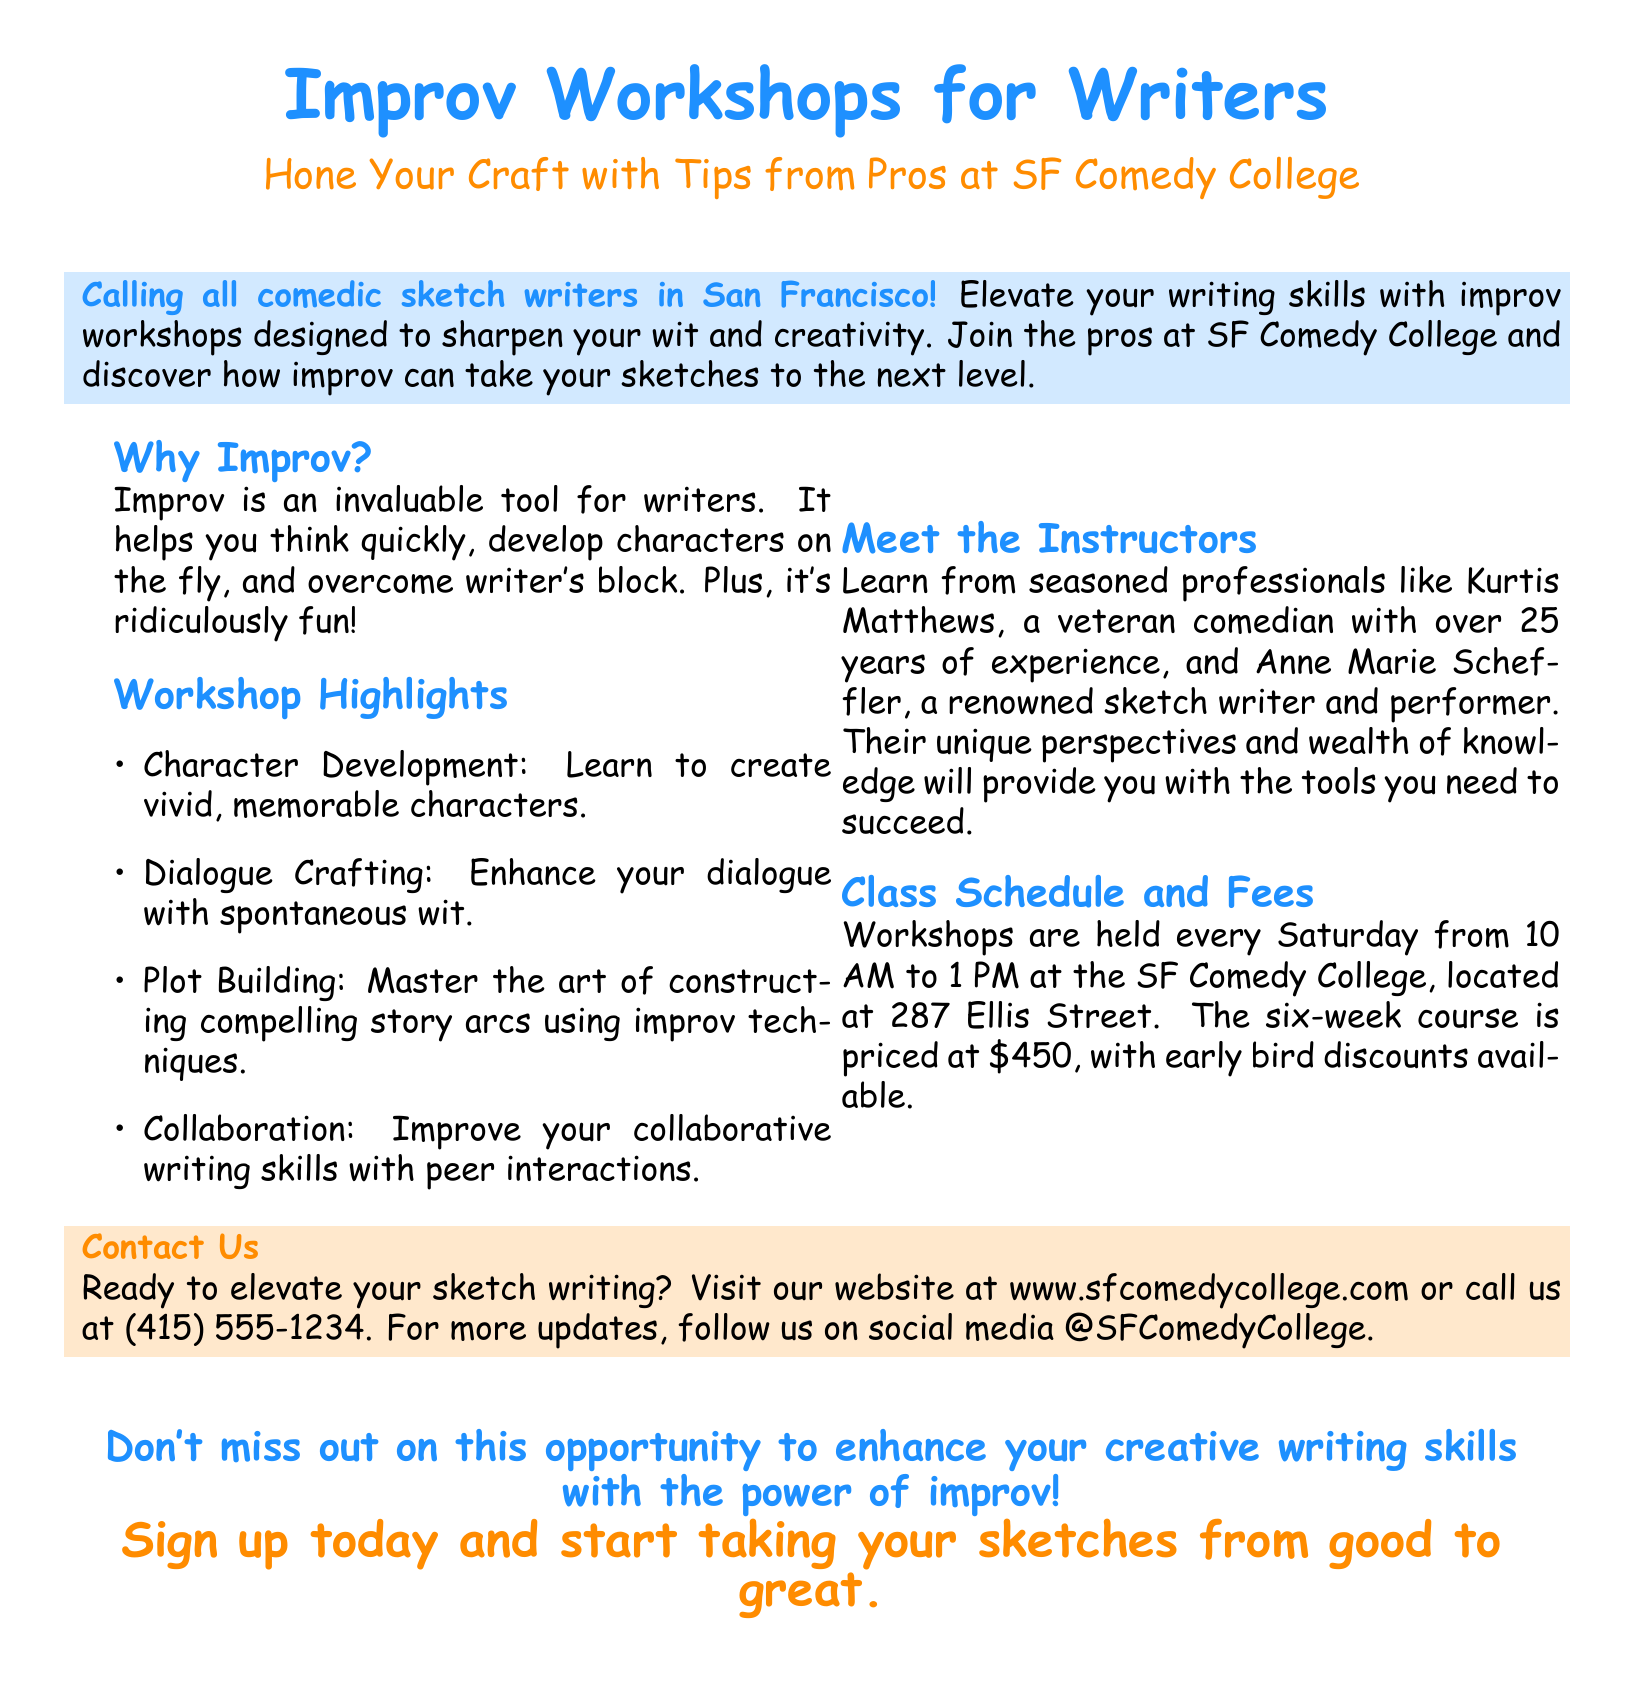What is the location of the workshops? The workshops are held at the SF Comedy College, located at 287 Ellis Street.
Answer: 287 Ellis Street Who is one of the instructors? The document mentions Kurtis Matthews and Anne Marie Scheffler as instructors.
Answer: Kurtis Matthews What day of the week are the workshops conducted? The document specifies that workshops are held every Saturday.
Answer: Saturday What is the total duration of the course? The document states that the course is a six-week workshop.
Answer: six weeks What time do the workshops start? The start time for the workshops is listed as 10 AM.
Answer: 10 AM What is the price of the six-week course? The document specifies that the course costs $450.
Answer: $450 What skill does improv help writers develop? The document suggests that improv helps writers think quickly.
Answer: think quickly Which two aspects of writing are highlighted in the workshops? The document lists character development and dialogue crafting as highlights.
Answer: character development and dialogue crafting What is one reason given for attending the workshops? The document states that attending the workshops will help overcome writer's block.
Answer: overcome writer's block 